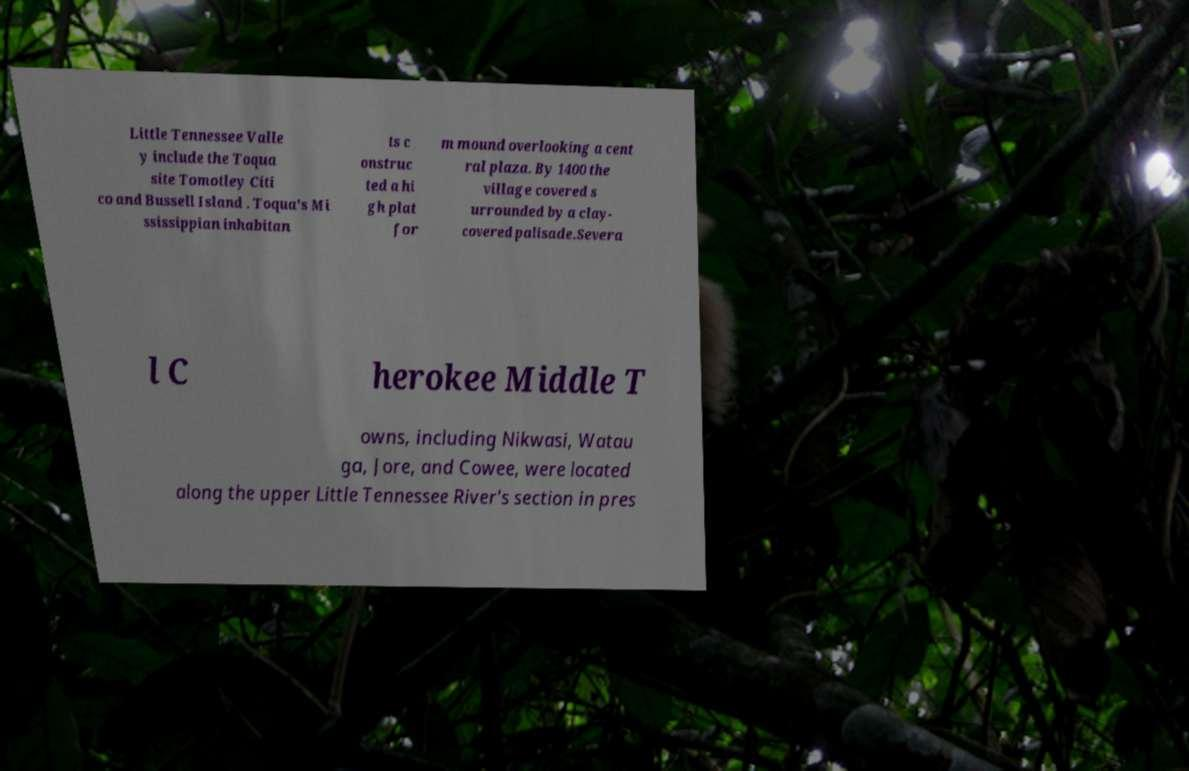Please identify and transcribe the text found in this image. Little Tennessee Valle y include the Toqua site Tomotley Citi co and Bussell Island . Toqua's Mi ssissippian inhabitan ts c onstruc ted a hi gh plat for m mound overlooking a cent ral plaza. By 1400 the village covered s urrounded by a clay- covered palisade.Severa l C herokee Middle T owns, including Nikwasi, Watau ga, Jore, and Cowee, were located along the upper Little Tennessee River's section in pres 